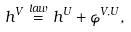<formula> <loc_0><loc_0><loc_500><loc_500>h ^ { V } \overset { l a w } { = } h ^ { U } + \varphi ^ { V , U } ,</formula> 